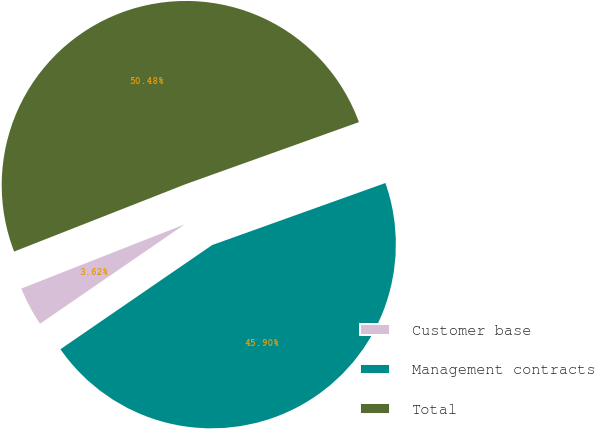Convert chart to OTSL. <chart><loc_0><loc_0><loc_500><loc_500><pie_chart><fcel>Customer base<fcel>Management contracts<fcel>Total<nl><fcel>3.62%<fcel>45.9%<fcel>50.49%<nl></chart> 